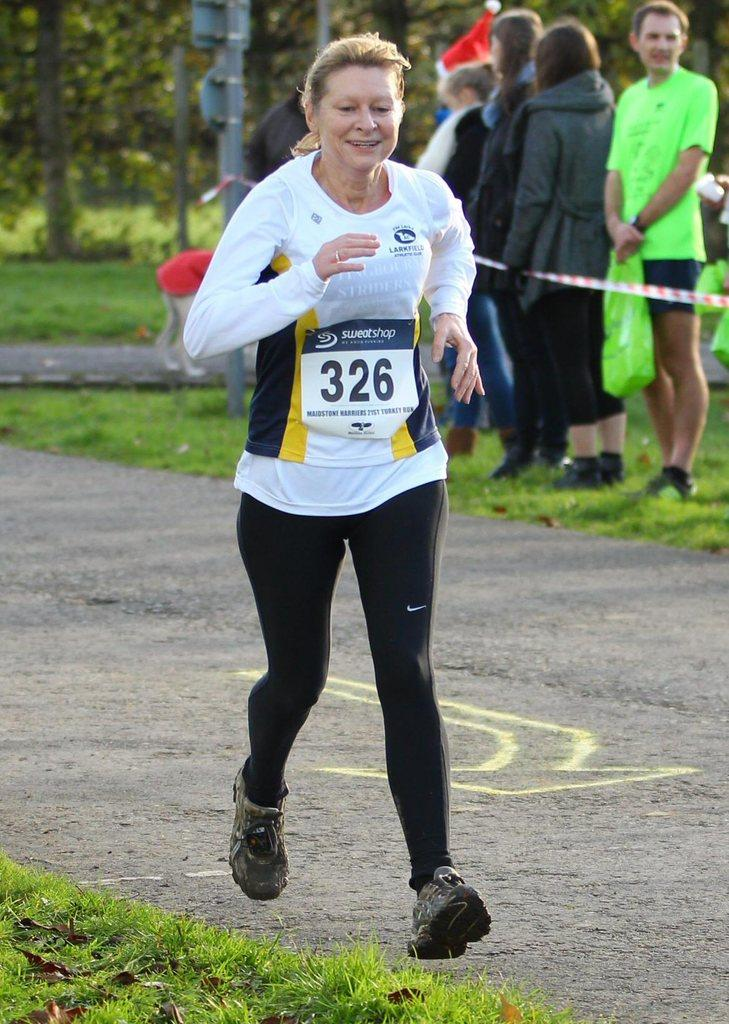What is the woman in the image doing? The woman is running in the image. Are there any other people in the image besides the woman? Yes, there are people standing on the side in the image. What can be seen in the background of the image? There is a pole and trees in the image. What type of terrain is visible in the image? There is grass on the ground in the image. What grade is the woman teaching in the image? There is no indication in the image that the woman is teaching, nor is there any reference to a grade. 